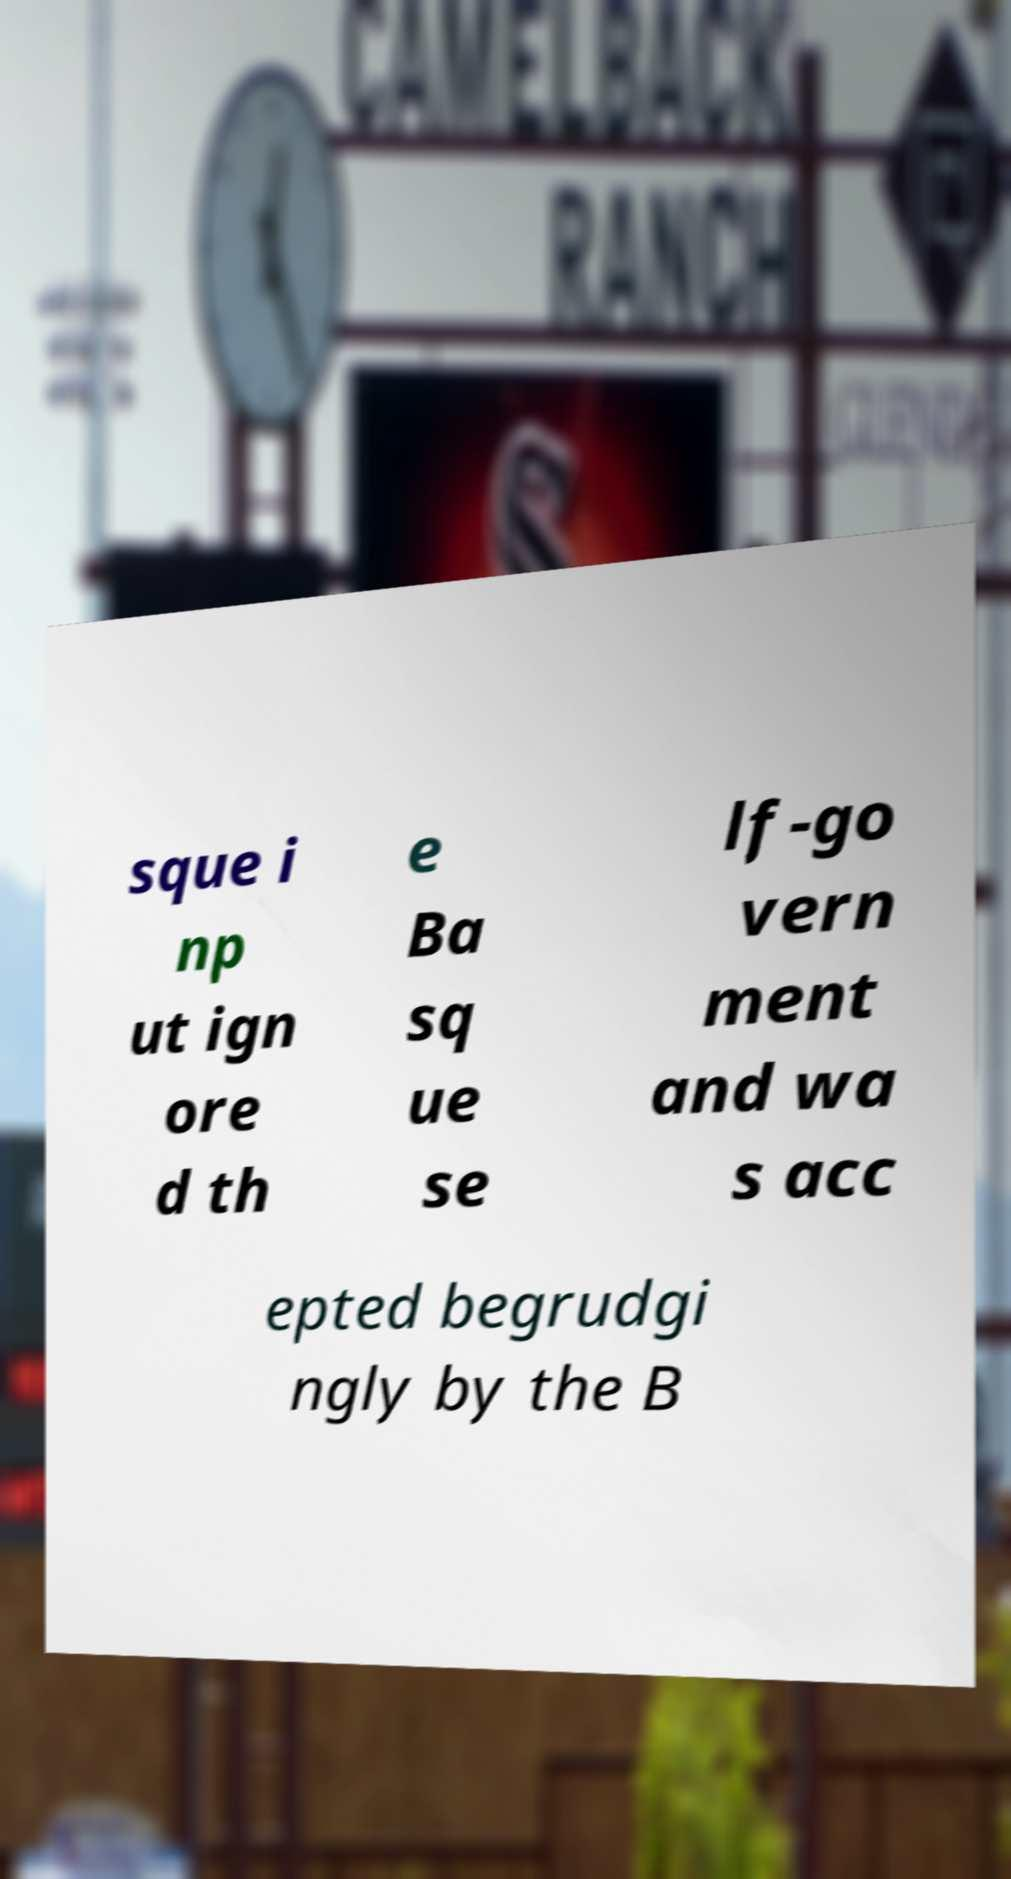Please identify and transcribe the text found in this image. sque i np ut ign ore d th e Ba sq ue se lf-go vern ment and wa s acc epted begrudgi ngly by the B 